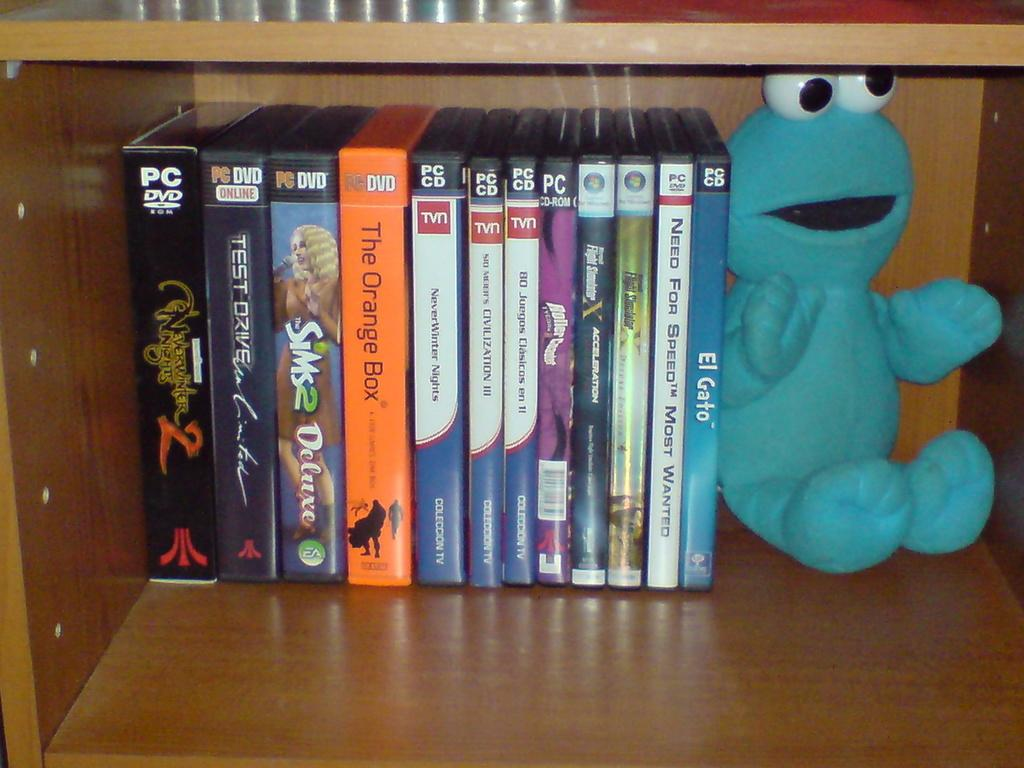<image>
Create a compact narrative representing the image presented. A collection of movies including El Gato, sitting on a shelf next to a stuffed animal. 